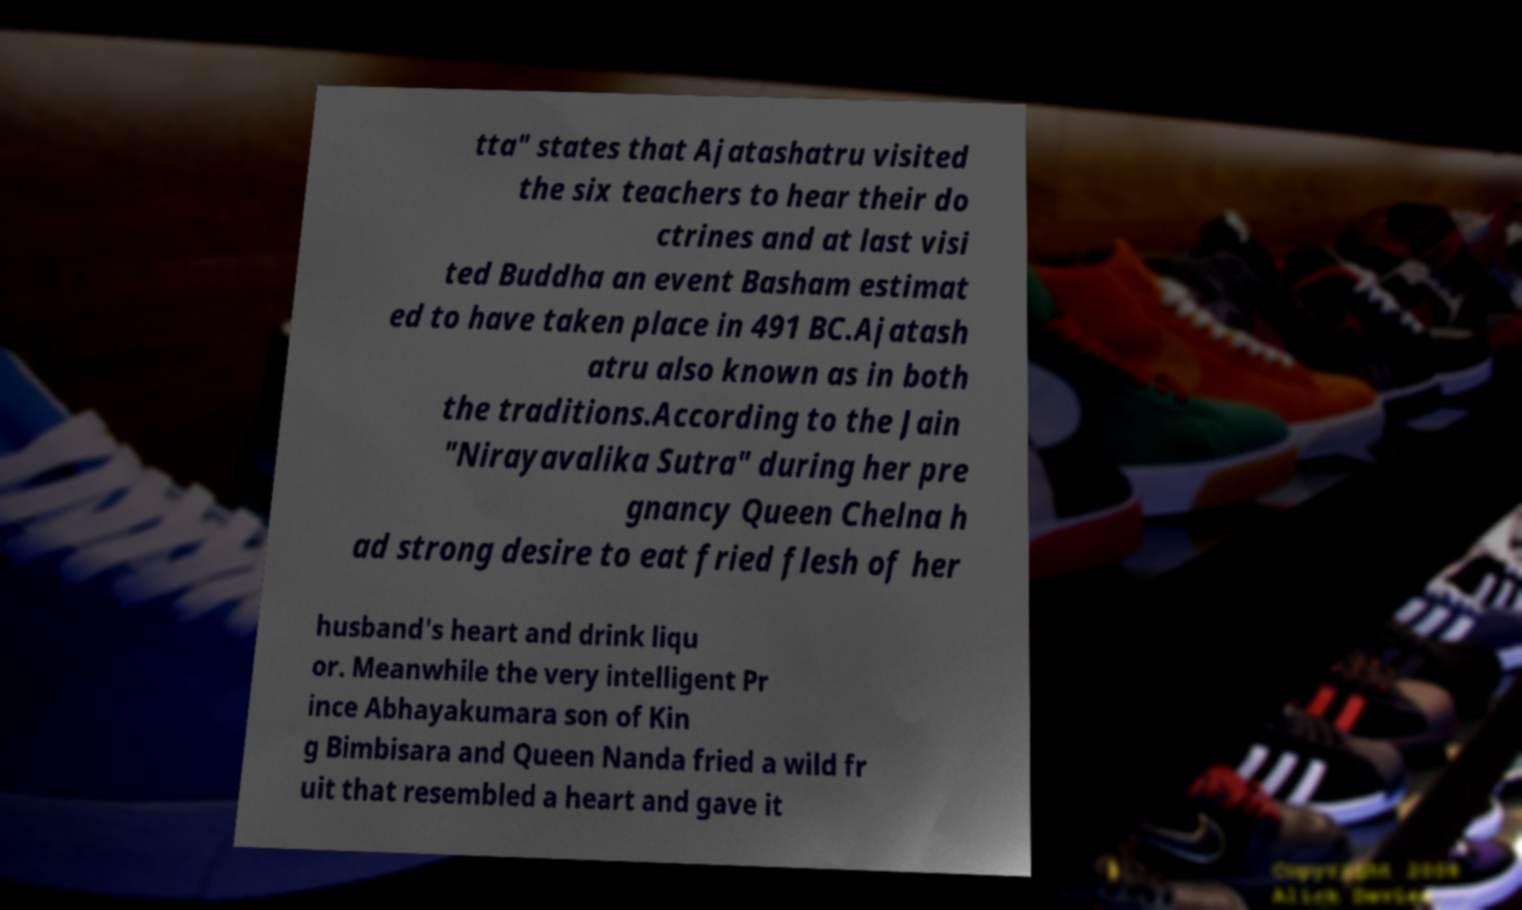For documentation purposes, I need the text within this image transcribed. Could you provide that? tta" states that Ajatashatru visited the six teachers to hear their do ctrines and at last visi ted Buddha an event Basham estimat ed to have taken place in 491 BC.Ajatash atru also known as in both the traditions.According to the Jain "Nirayavalika Sutra" during her pre gnancy Queen Chelna h ad strong desire to eat fried flesh of her husband's heart and drink liqu or. Meanwhile the very intelligent Pr ince Abhayakumara son of Kin g Bimbisara and Queen Nanda fried a wild fr uit that resembled a heart and gave it 